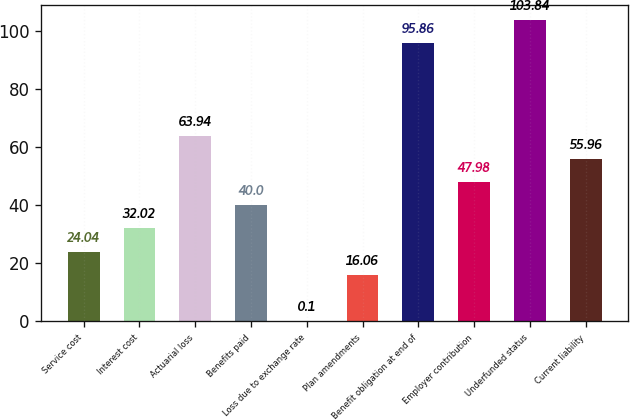Convert chart. <chart><loc_0><loc_0><loc_500><loc_500><bar_chart><fcel>Service cost<fcel>Interest cost<fcel>Actuarial loss<fcel>Benefits paid<fcel>Loss due to exchange rate<fcel>Plan amendments<fcel>Benefit obligation at end of<fcel>Employer contribution<fcel>Underfunded status<fcel>Current liability<nl><fcel>24.04<fcel>32.02<fcel>63.94<fcel>40<fcel>0.1<fcel>16.06<fcel>95.86<fcel>47.98<fcel>103.84<fcel>55.96<nl></chart> 